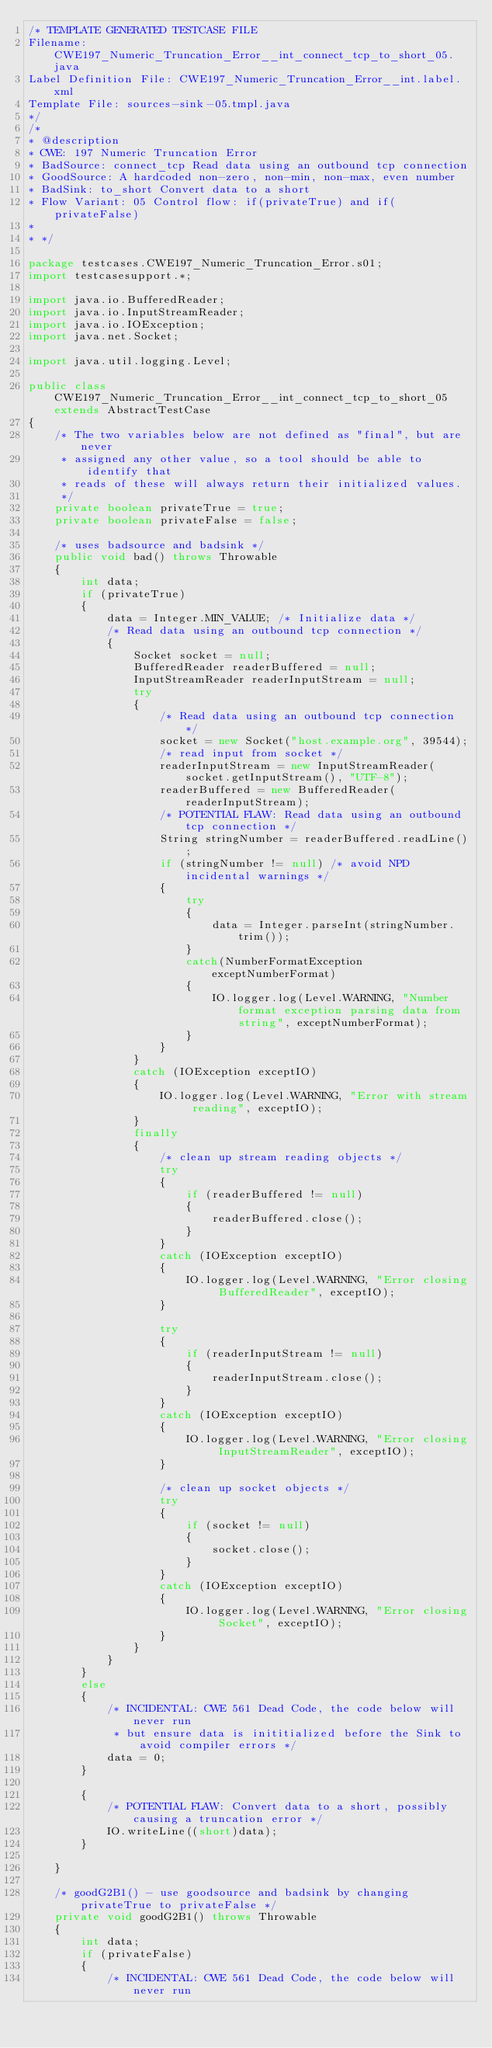Convert code to text. <code><loc_0><loc_0><loc_500><loc_500><_Java_>/* TEMPLATE GENERATED TESTCASE FILE
Filename: CWE197_Numeric_Truncation_Error__int_connect_tcp_to_short_05.java
Label Definition File: CWE197_Numeric_Truncation_Error__int.label.xml
Template File: sources-sink-05.tmpl.java
*/
/*
* @description
* CWE: 197 Numeric Truncation Error
* BadSource: connect_tcp Read data using an outbound tcp connection
* GoodSource: A hardcoded non-zero, non-min, non-max, even number
* BadSink: to_short Convert data to a short
* Flow Variant: 05 Control flow: if(privateTrue) and if(privateFalse)
*
* */

package testcases.CWE197_Numeric_Truncation_Error.s01;
import testcasesupport.*;

import java.io.BufferedReader;
import java.io.InputStreamReader;
import java.io.IOException;
import java.net.Socket;

import java.util.logging.Level;

public class CWE197_Numeric_Truncation_Error__int_connect_tcp_to_short_05 extends AbstractTestCase
{
    /* The two variables below are not defined as "final", but are never
     * assigned any other value, so a tool should be able to identify that
     * reads of these will always return their initialized values.
     */
    private boolean privateTrue = true;
    private boolean privateFalse = false;

    /* uses badsource and badsink */
    public void bad() throws Throwable
    {
        int data;
        if (privateTrue)
        {
            data = Integer.MIN_VALUE; /* Initialize data */
            /* Read data using an outbound tcp connection */
            {
                Socket socket = null;
                BufferedReader readerBuffered = null;
                InputStreamReader readerInputStream = null;
                try
                {
                    /* Read data using an outbound tcp connection */
                    socket = new Socket("host.example.org", 39544);
                    /* read input from socket */
                    readerInputStream = new InputStreamReader(socket.getInputStream(), "UTF-8");
                    readerBuffered = new BufferedReader(readerInputStream);
                    /* POTENTIAL FLAW: Read data using an outbound tcp connection */
                    String stringNumber = readerBuffered.readLine();
                    if (stringNumber != null) /* avoid NPD incidental warnings */
                    {
                        try
                        {
                            data = Integer.parseInt(stringNumber.trim());
                        }
                        catch(NumberFormatException exceptNumberFormat)
                        {
                            IO.logger.log(Level.WARNING, "Number format exception parsing data from string", exceptNumberFormat);
                        }
                    }
                }
                catch (IOException exceptIO)
                {
                    IO.logger.log(Level.WARNING, "Error with stream reading", exceptIO);
                }
                finally
                {
                    /* clean up stream reading objects */
                    try
                    {
                        if (readerBuffered != null)
                        {
                            readerBuffered.close();
                        }
                    }
                    catch (IOException exceptIO)
                    {
                        IO.logger.log(Level.WARNING, "Error closing BufferedReader", exceptIO);
                    }

                    try
                    {
                        if (readerInputStream != null)
                        {
                            readerInputStream.close();
                        }
                    }
                    catch (IOException exceptIO)
                    {
                        IO.logger.log(Level.WARNING, "Error closing InputStreamReader", exceptIO);
                    }

                    /* clean up socket objects */
                    try
                    {
                        if (socket != null)
                        {
                            socket.close();
                        }
                    }
                    catch (IOException exceptIO)
                    {
                        IO.logger.log(Level.WARNING, "Error closing Socket", exceptIO);
                    }
                }
            }
        }
        else
        {
            /* INCIDENTAL: CWE 561 Dead Code, the code below will never run
             * but ensure data is inititialized before the Sink to avoid compiler errors */
            data = 0;
        }

        {
            /* POTENTIAL FLAW: Convert data to a short, possibly causing a truncation error */
            IO.writeLine((short)data);
        }

    }

    /* goodG2B1() - use goodsource and badsink by changing privateTrue to privateFalse */
    private void goodG2B1() throws Throwable
    {
        int data;
        if (privateFalse)
        {
            /* INCIDENTAL: CWE 561 Dead Code, the code below will never run</code> 